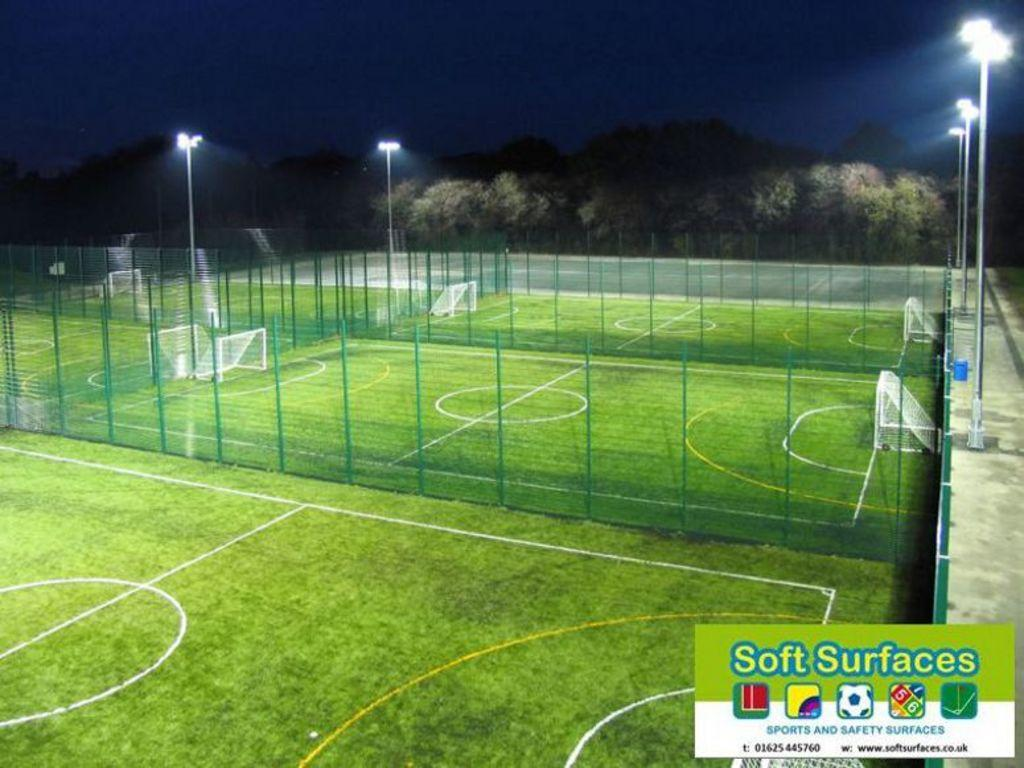<image>
Describe the image concisely. Soft Surfaces in the UK makes sports and safety surfaces 